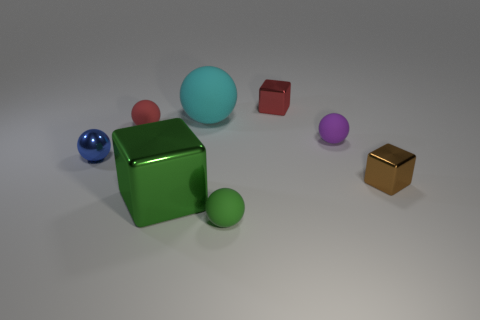Subtract all red spheres. How many spheres are left? 4 Subtract all small green rubber spheres. How many spheres are left? 4 Subtract all gray spheres. Subtract all blue cylinders. How many spheres are left? 5 Add 2 shiny objects. How many objects exist? 10 Subtract all cubes. How many objects are left? 5 Add 3 brown metal objects. How many brown metal objects are left? 4 Add 1 big purple metal blocks. How many big purple metal blocks exist? 1 Subtract 1 green cubes. How many objects are left? 7 Subtract all green metallic blocks. Subtract all tiny red rubber objects. How many objects are left? 6 